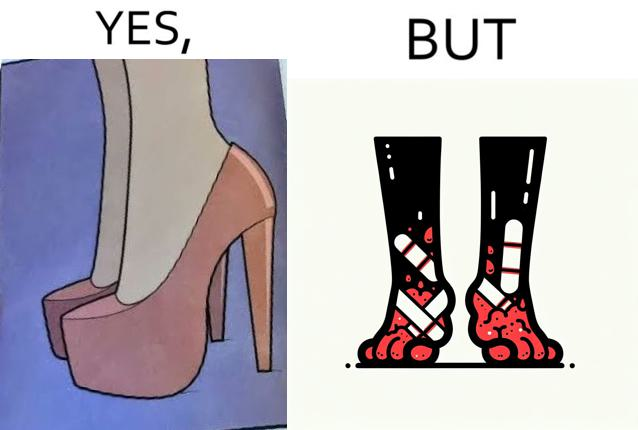Does this image contain satire or humor? Yes, this image is satirical. 